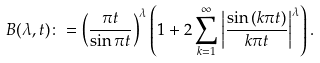<formula> <loc_0><loc_0><loc_500><loc_500>B ( \lambda , t ) \colon = \left ( \frac { \pi t } { \sin \pi t } \right ) ^ { \lambda } \left ( 1 + 2 \sum _ { k = 1 } ^ { \infty } \left | \frac { \sin \left ( k \pi t \right ) } { k \pi t } \right | ^ { \lambda } \right ) .</formula> 